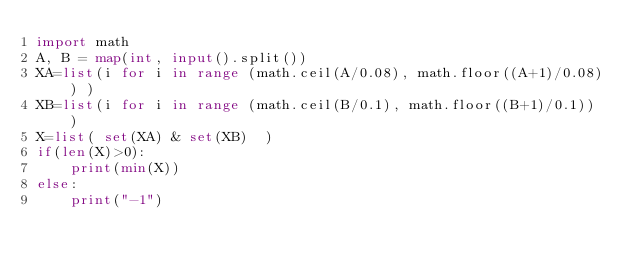<code> <loc_0><loc_0><loc_500><loc_500><_Python_>import math
A, B = map(int, input().split())
XA=list(i for i in range (math.ceil(A/0.08), math.floor((A+1)/0.08)) )
XB=list(i for i in range (math.ceil(B/0.1), math.floor((B+1)/0.1)) )
X=list( set(XA) & set(XB)  )
if(len(X)>0):
    print(min(X))
else:
    print("-1")</code> 